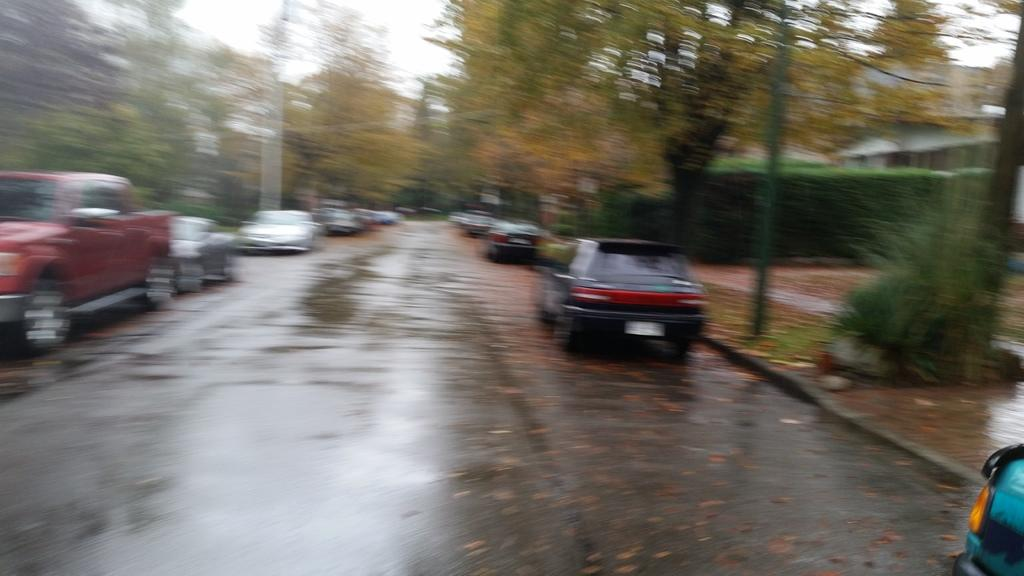What is the condition of the road in the image? The road in the image is wet. What can be seen on the road in the image? There are vehicles on both sides of the road. What type of vegetation is present on both sides of the road? Plants and trees are present on both sides of the road. What type of cloud can be seen bursting above the trees in the image? There is no cloud present in the image, and therefore no bursting cloud can be observed. 